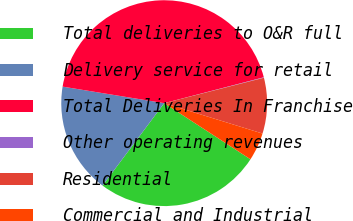Convert chart to OTSL. <chart><loc_0><loc_0><loc_500><loc_500><pie_chart><fcel>Total deliveries to O&R full<fcel>Delivery service for retail<fcel>Total Deliveries In Franchise<fcel>Other operating revenues<fcel>Residential<fcel>Commercial and Industrial<nl><fcel>26.04%<fcel>17.35%<fcel>43.39%<fcel>0.07%<fcel>8.74%<fcel>4.41%<nl></chart> 